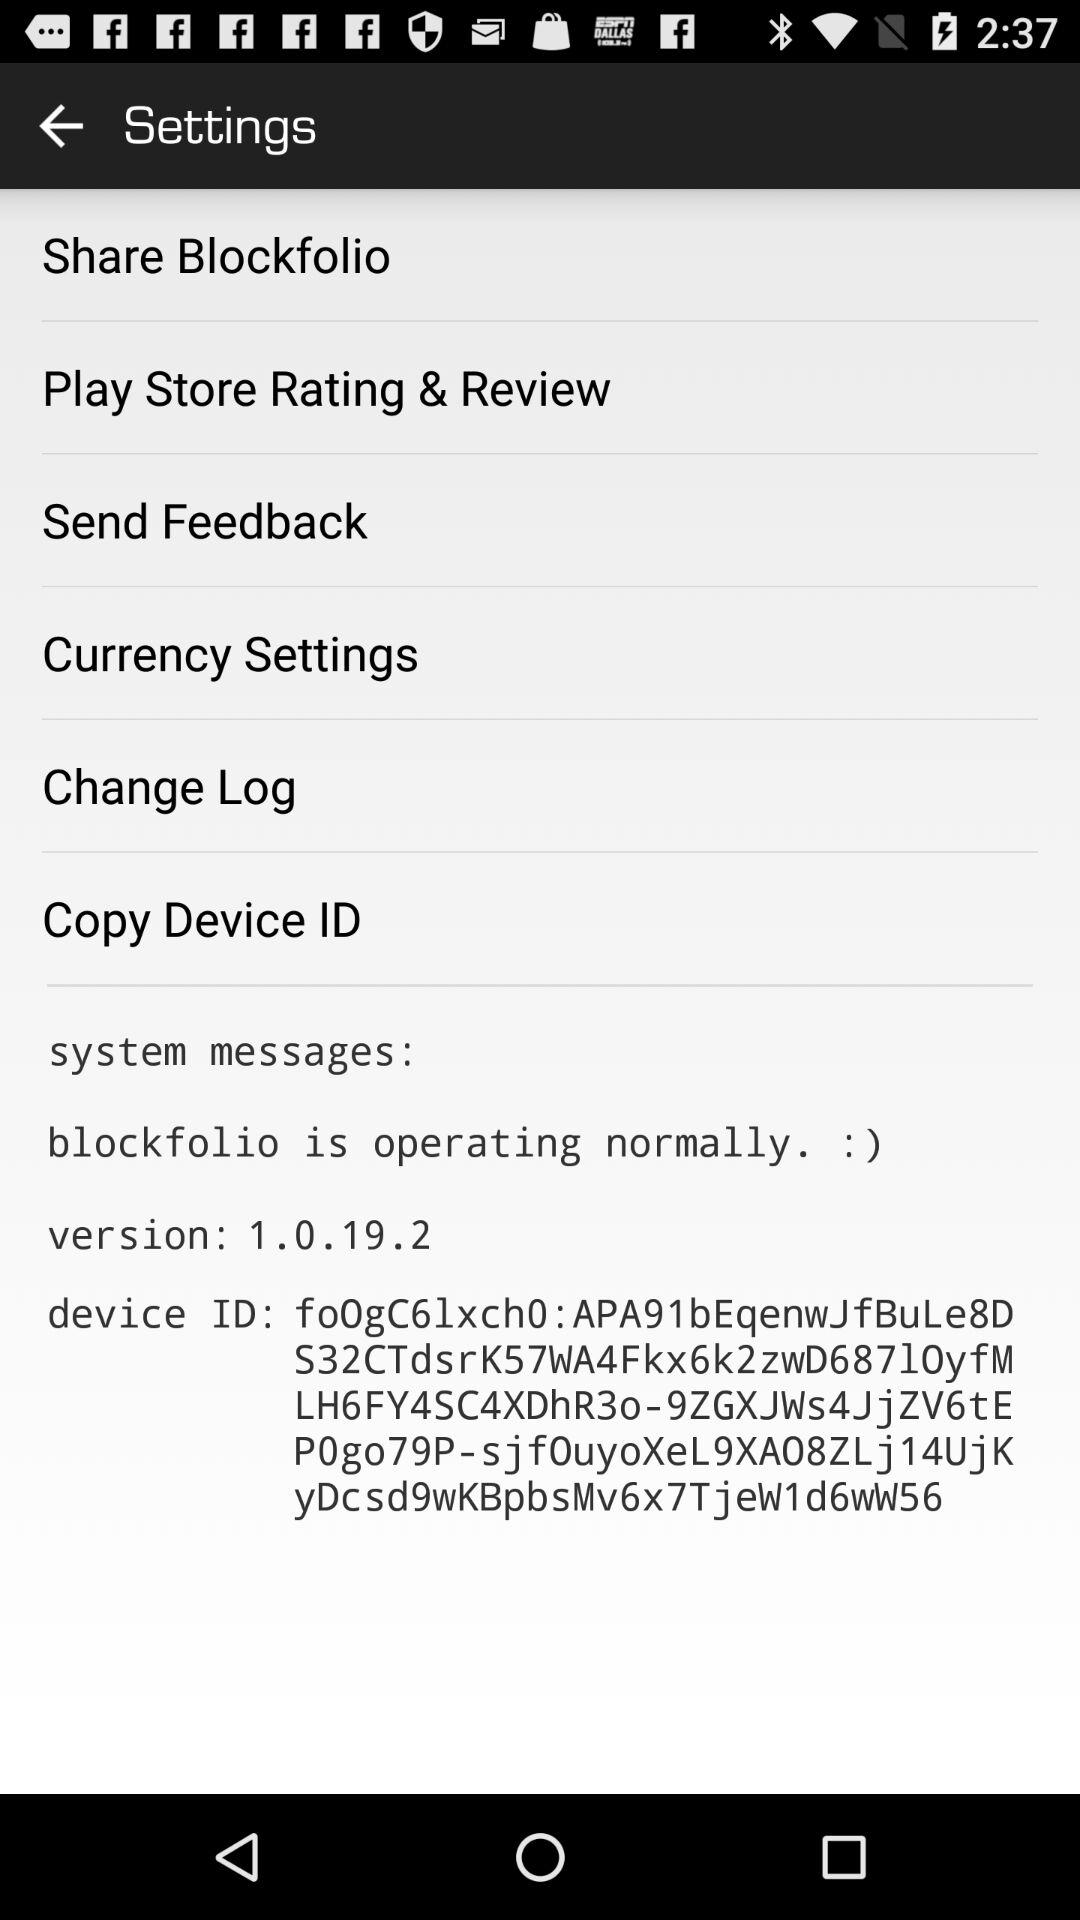What is the version? The version is 1.0.19.2. 